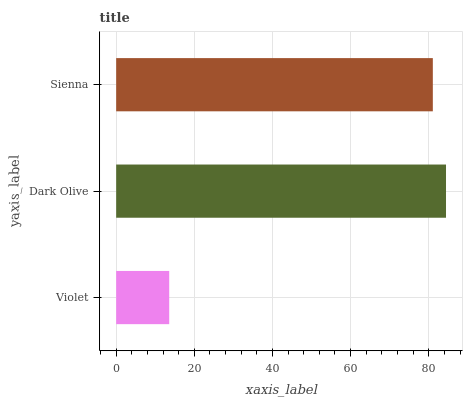Is Violet the minimum?
Answer yes or no. Yes. Is Dark Olive the maximum?
Answer yes or no. Yes. Is Sienna the minimum?
Answer yes or no. No. Is Sienna the maximum?
Answer yes or no. No. Is Dark Olive greater than Sienna?
Answer yes or no. Yes. Is Sienna less than Dark Olive?
Answer yes or no. Yes. Is Sienna greater than Dark Olive?
Answer yes or no. No. Is Dark Olive less than Sienna?
Answer yes or no. No. Is Sienna the high median?
Answer yes or no. Yes. Is Sienna the low median?
Answer yes or no. Yes. Is Dark Olive the high median?
Answer yes or no. No. Is Dark Olive the low median?
Answer yes or no. No. 